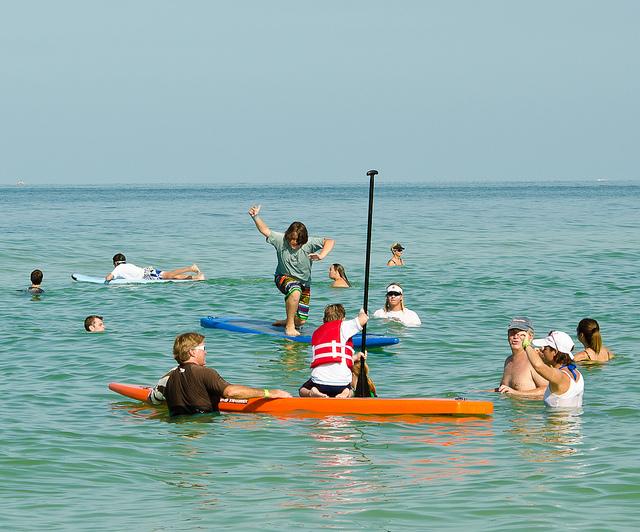What is orange in the water?
Concise answer only. Surfboard. Is it winter?
Keep it brief. No. Is there a surfboard?
Give a very brief answer. Yes. How many people are in this photo?
Give a very brief answer. 12. 